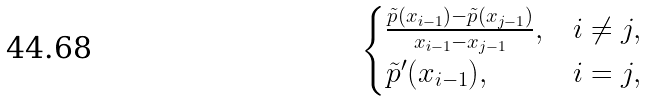Convert formula to latex. <formula><loc_0><loc_0><loc_500><loc_500>\begin{cases} \frac { \tilde { p } ( x _ { i - 1 } ) - \tilde { p } ( x _ { j - 1 } ) } { x _ { i - 1 } - x _ { j - 1 } } , & i \neq j , \\ \tilde { p } ^ { \prime } ( x _ { i - 1 } ) , & i = j , \end{cases}</formula> 